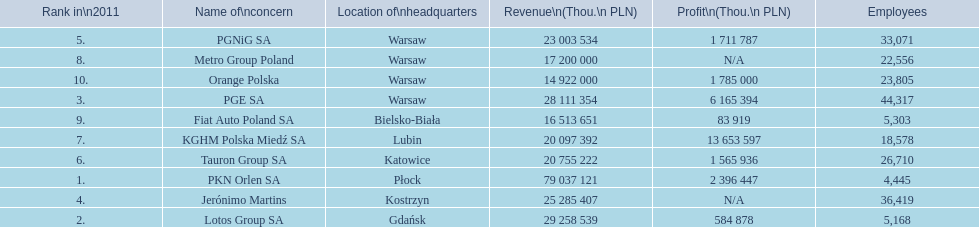Which company had the most employees? PGE SA. 